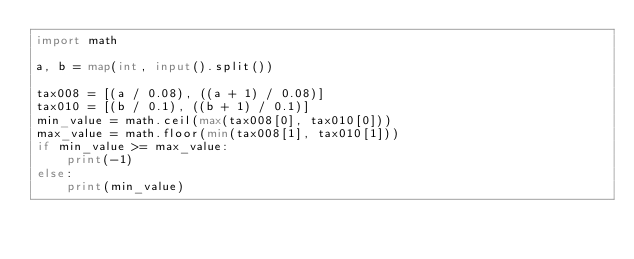Convert code to text. <code><loc_0><loc_0><loc_500><loc_500><_Python_>import math

a, b = map(int, input().split())

tax008 = [(a / 0.08), ((a + 1) / 0.08)]
tax010 = [(b / 0.1), ((b + 1) / 0.1)]
min_value = math.ceil(max(tax008[0], tax010[0]))
max_value = math.floor(min(tax008[1], tax010[1]))
if min_value >= max_value:
    print(-1)
else:
    print(min_value)
</code> 